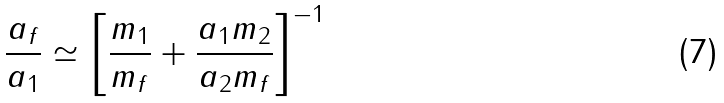<formula> <loc_0><loc_0><loc_500><loc_500>\frac { a _ { f } } { a _ { 1 } } \simeq \left [ \frac { m _ { 1 } } { m _ { f } } + \frac { a _ { 1 } m _ { 2 } } { a _ { 2 } m _ { f } } \right ] ^ { - 1 }</formula> 